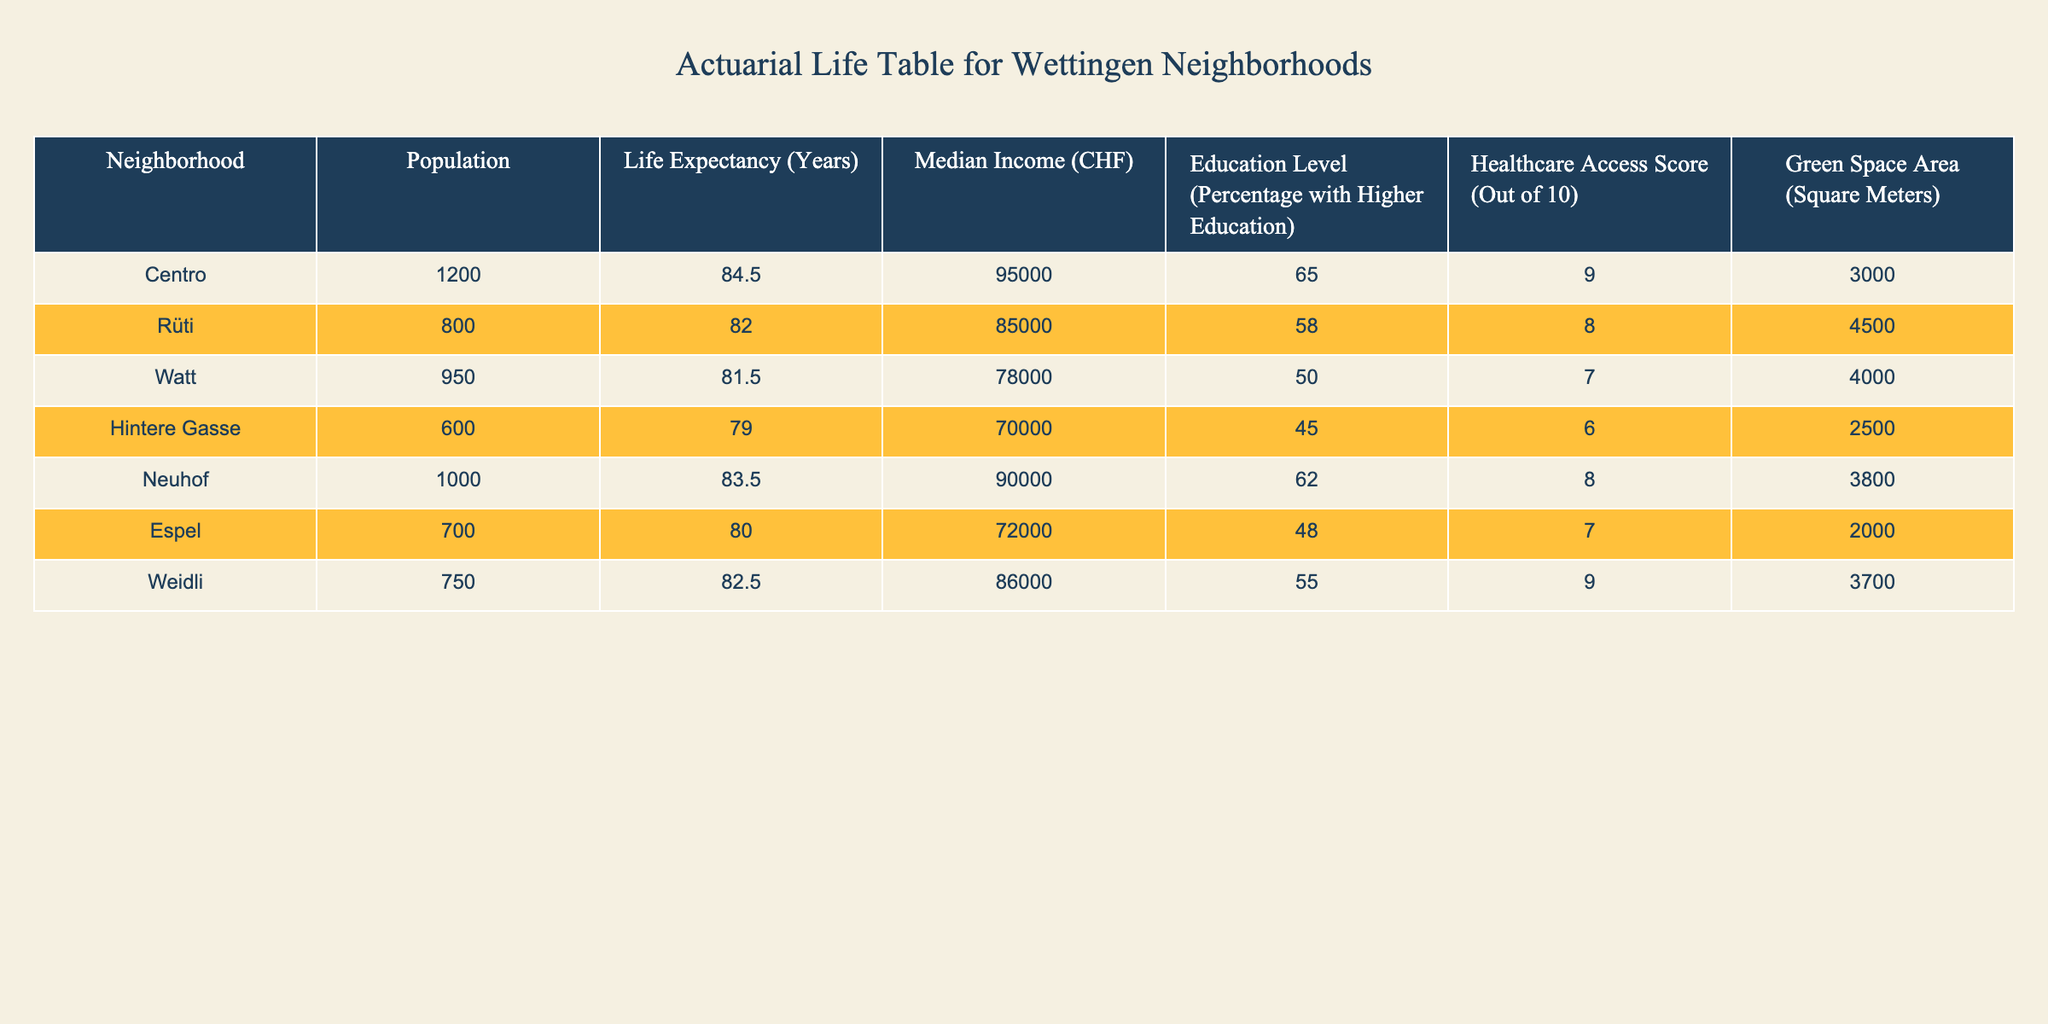What is the life expectancy in the Centro neighborhood? The table directly provides the life expectancy for the Centro neighborhood as 84.5 years.
Answer: 84.5 Which neighborhood has the highest median income? By examining the Median Income column in the table, Centro leads with a median income of 95,000 CHF, higher than all other neighborhoods.
Answer: Centro What is the average life expectancy across all neighborhoods? To find the average, sum the life expectancy values: 84.5 + 82.0 + 81.5 + 79.0 + 83.5 + 80.0 + 82.5 = 483.0. There are 7 neighborhoods, so the average is 483.0 / 7 = 69.0.
Answer: 69.0 Is the healthcare access score in Neuhof greater than or equal to 8? Neuhof has a healthcare access score of 8, making it true that the score is greater than or equal to 8.
Answer: Yes Which neighborhood has the lowest life expectancy, and what is it? By scanning the Life Expectancy column, Hintere Gasse has the lowest life expectancy at 79.0 years, highlighted by its values compared to the other neighborhoods.
Answer: Hintere Gasse, 79.0 What is the total green space area for neighborhoods with median income less than 80,000 CHF? The neighborhoods with median income less than 80,000 CHF are Watt (4,000 sqm) and Hintere Gasse (2,500 sqm). Summing these gives 4,000 + 2,500 = 6,500 square meters.
Answer: 6,500 Does Rüti have a higher percentage of residents with higher education compared to Weidli? Rüti has 58% with higher education, while Weidli has 55%. Since 58% is greater than 55%, the statement is true.
Answer: Yes What is the difference in life expectancy between Neuhof and Espel? The life expectancy for Neuhof is 83.5 years and for Espel it is 80.0 years. The difference can be calculated as 83.5 - 80.0 = 3.5 years.
Answer: 3.5 Which neighborhoods have a healthcare access score of 9, and what is their median income? The neighborhoods with a healthcare access score of 9 are Centro (95,000 CHF) and Weidli (86,000 CHF), listed together from the Healthcare Access Score column.
Answer: Centro: 95,000 CHF, Weidli: 86,000 CHF 